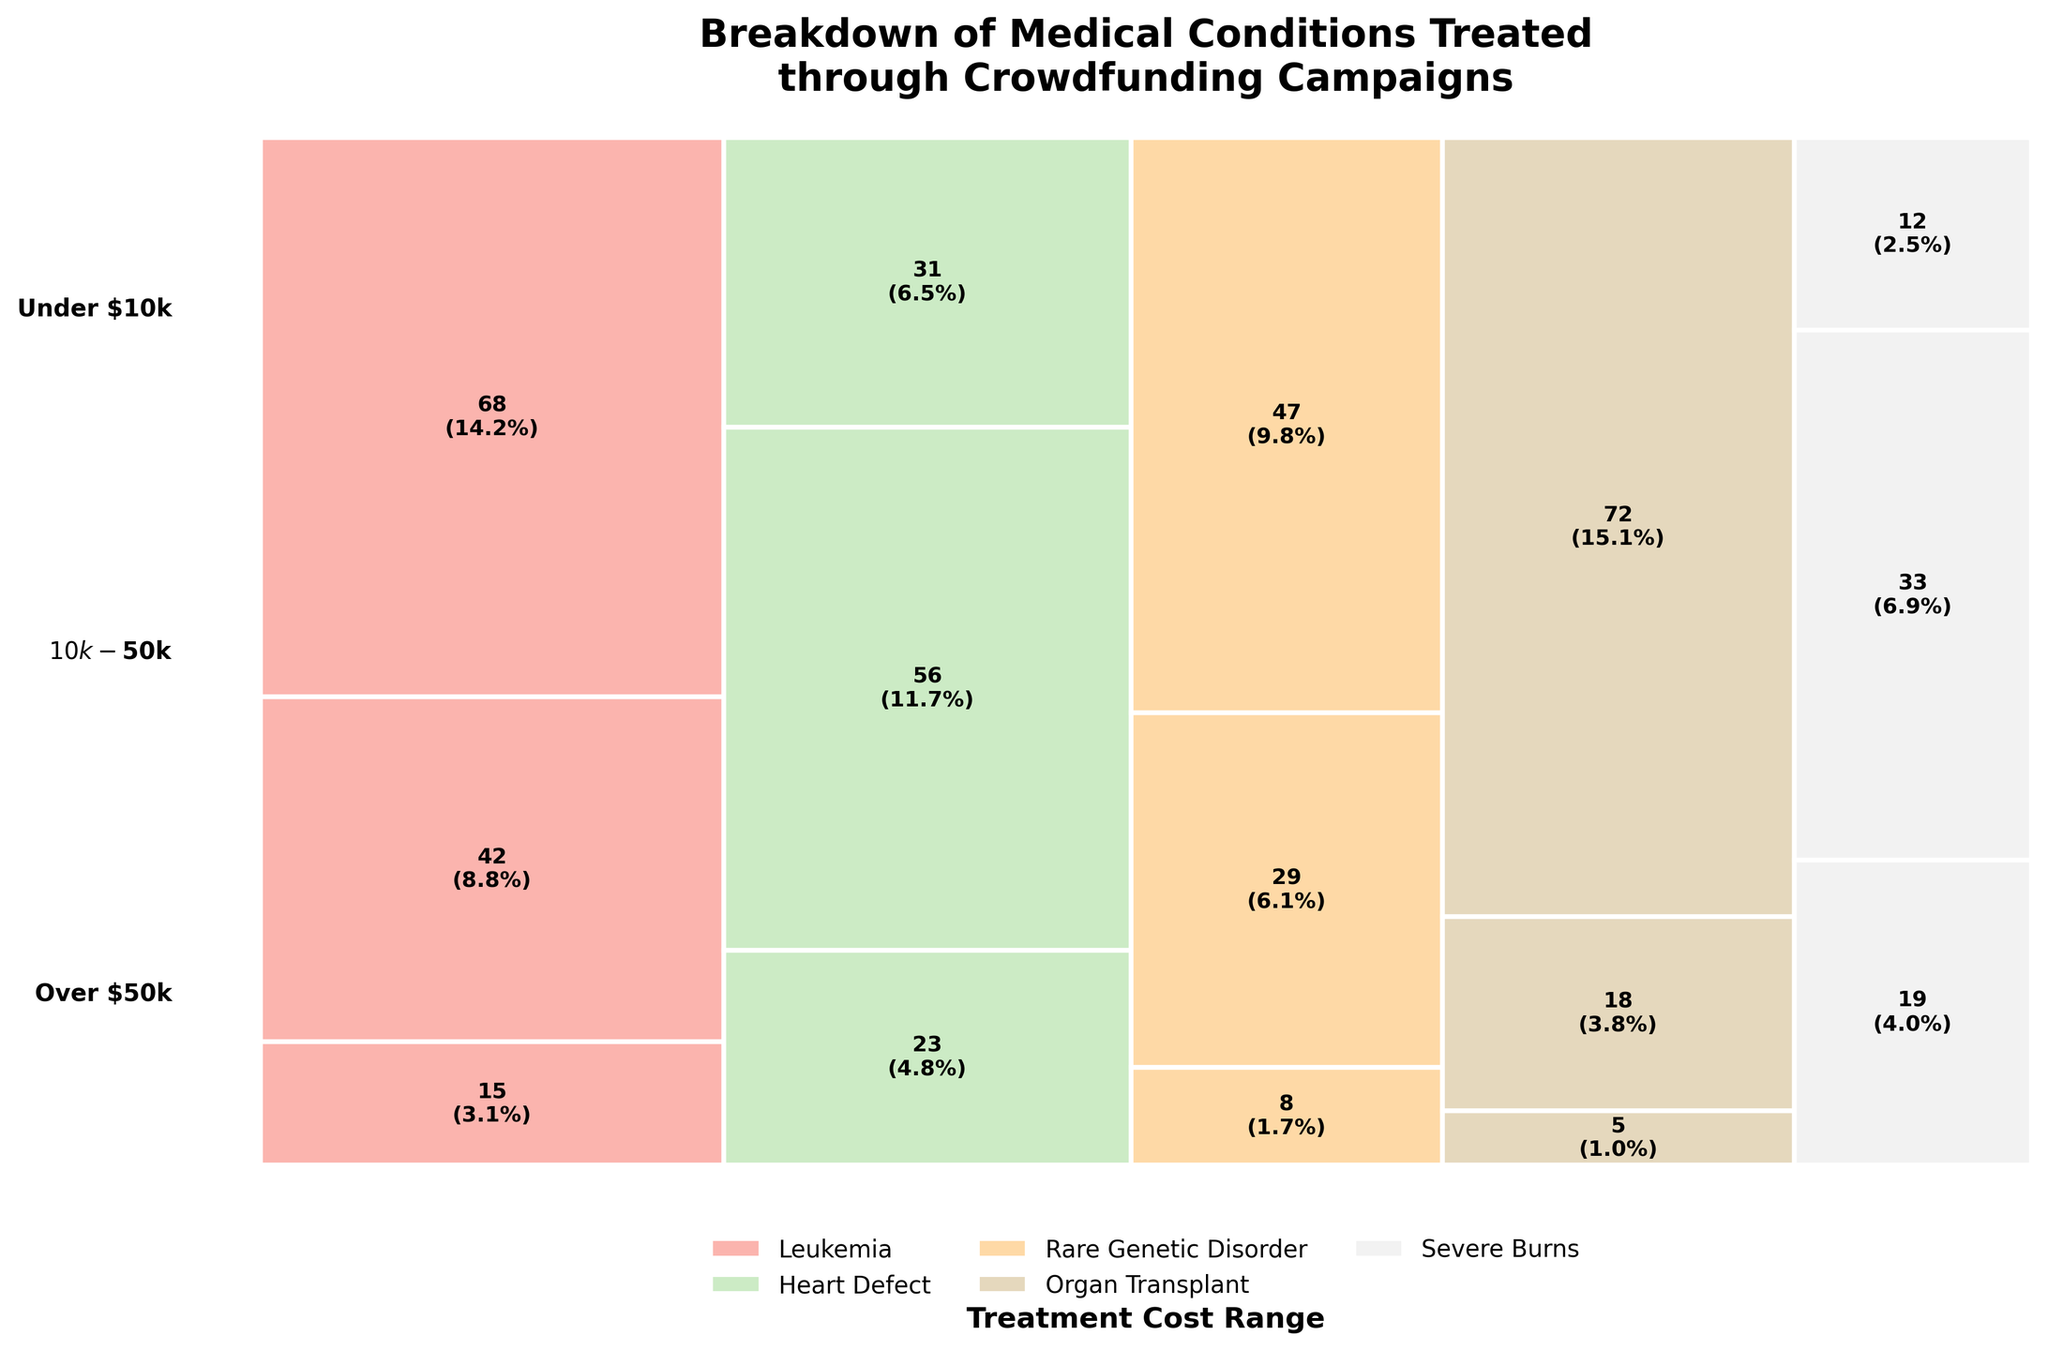What is the title of the plot? The title is found at the top of the plot and usually summarizes the main insight or purpose of the plot. Here, the title is clearly stated.
Answer: Breakdown of Medical Conditions Treated through Crowdfunding Campaigns Which medical condition has the highest number of campaigns in the "Over $50k" treatment cost range? Look for the medical condition associated with the largest rectangular area in the "Over $50k" range segment of the plot.
Answer: Organ Transplant What is the total number of campaigns for Severe Burns? Sum the numbers from each treatment cost range for the Severe Burns category: 19 (Under $10k) + 33 ($10k-$50k) + 12 (Over $50k) = 64.
Answer: 64 How does the number of campaigns for Heart Defect in the "$10k-$50k" range compare to Leukemia in the same range? Find the numbers for Heart Defect and Leukemia in the "$10k-$50k" range and compare them: 56 (Heart Defect) vs. 42 (Leukemia).
Answer: Heart Defect has more campaigns Which treatment cost range has the least number of campaigns for Rare Genetic Disorder? Look at the three segments for Rare Genetic Disorder and determine which has the smallest number: 8 (Under $10k), 29 ($10k-$50k), and 47 (Over $50k).
Answer: Under $10k What percentage of the total campaigns are for Leukemia in the "Under $10k" treatment cost range? Find the number of campaigns for Leukemia in the "Under $10k" range (15), then divide by the total number of campaigns (396), and multiply by 100 to get the percentage: (15/396) * 100 ≈ 3.8%.
Answer: About 3.8% How many campaigns are there in the "$10k-$50k" range for both Heart Defect and Rare Genetic Disorder combined? Add the number of campaigns for Heart Defect and Rare Genetic Disorder in the "$10k-$50k" range: 56 (Heart Defect) + 29 (Rare Genetic Disorder) = 85.
Answer: 85 What is the most common treatment cost range for Organ Transplant campaigns? Identify which of the three treatment cost ranges has the largest number of campaigns for Organ Transplant: 5 (Under $10k), 18 ($10k-$50k), and 72 (Over $50k).
Answer: Over $50k 